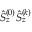<formula> <loc_0><loc_0><loc_500><loc_500>\hat { S } _ { z } ^ { ( 0 ) } \hat { S } _ { z } ^ { ( k ) }</formula> 